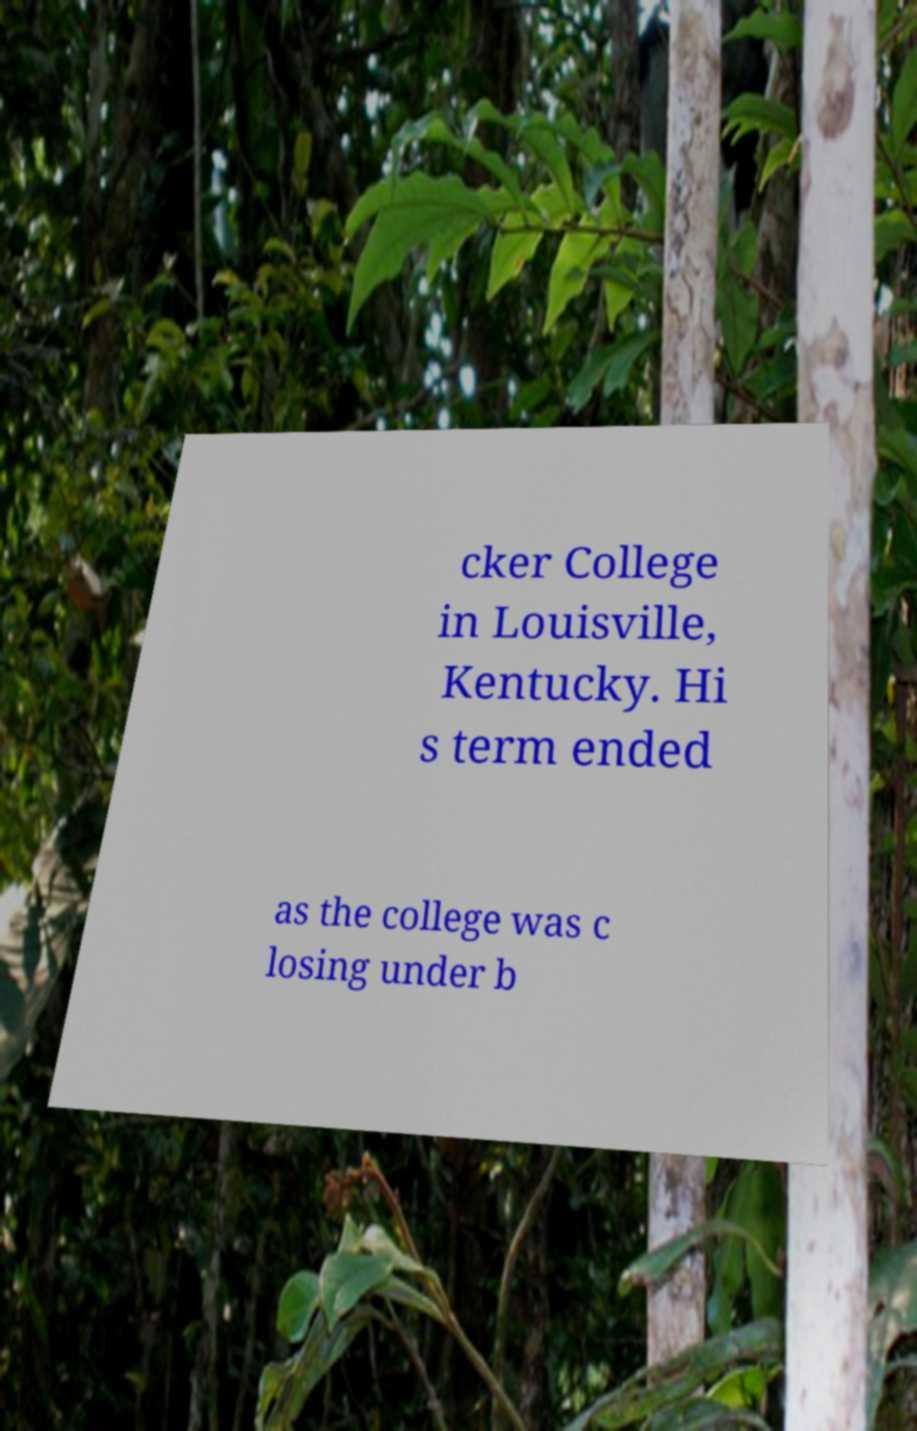Can you accurately transcribe the text from the provided image for me? cker College in Louisville, Kentucky. Hi s term ended as the college was c losing under b 